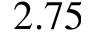<formula> <loc_0><loc_0><loc_500><loc_500>2 . 7 5</formula> 